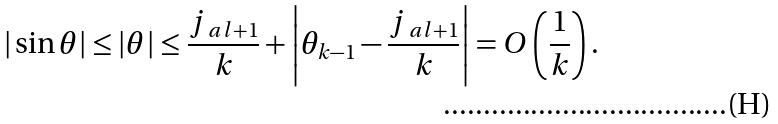Convert formula to latex. <formula><loc_0><loc_0><loc_500><loc_500>| \sin \theta | \leq | \theta | \leq \frac { j _ { \ a l + 1 } } { k } + \left | \theta _ { k - 1 } - \frac { j _ { \ a l + 1 } } { k } \right | = O \left ( \frac { 1 } { k } \right ) .</formula> 